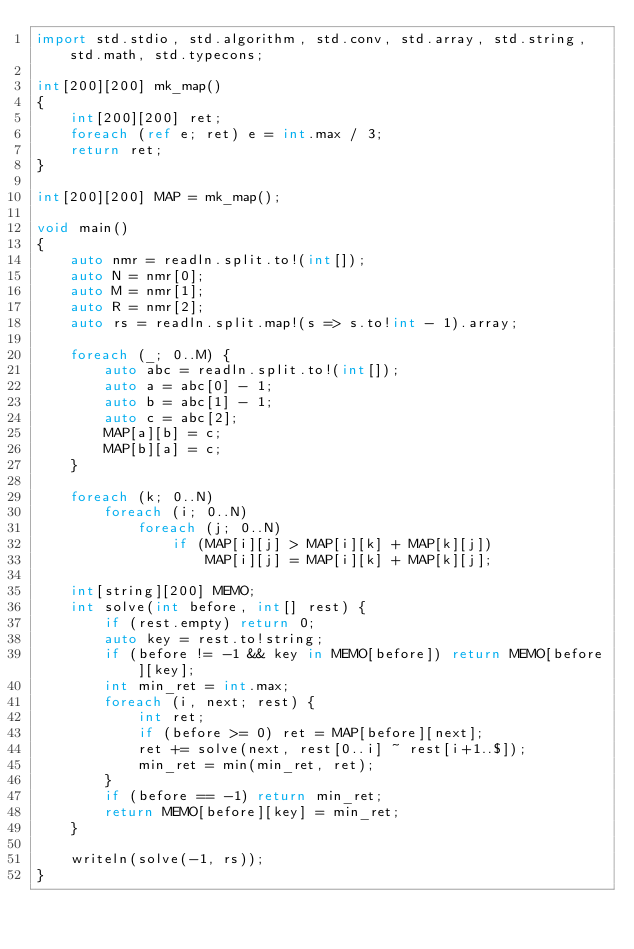Convert code to text. <code><loc_0><loc_0><loc_500><loc_500><_D_>import std.stdio, std.algorithm, std.conv, std.array, std.string, std.math, std.typecons;

int[200][200] mk_map()
{
    int[200][200] ret;
    foreach (ref e; ret) e = int.max / 3;
    return ret;
}

int[200][200] MAP = mk_map();

void main()
{
    auto nmr = readln.split.to!(int[]);
    auto N = nmr[0];
    auto M = nmr[1];
    auto R = nmr[2];
    auto rs = readln.split.map!(s => s.to!int - 1).array;

    foreach (_; 0..M) {
        auto abc = readln.split.to!(int[]);
        auto a = abc[0] - 1;
        auto b = abc[1] - 1;
        auto c = abc[2];
        MAP[a][b] = c;
        MAP[b][a] = c;
    }

    foreach (k; 0..N)
        foreach (i; 0..N)
            foreach (j; 0..N)
                if (MAP[i][j] > MAP[i][k] + MAP[k][j])
                    MAP[i][j] = MAP[i][k] + MAP[k][j];

    int[string][200] MEMO;
    int solve(int before, int[] rest) {
        if (rest.empty) return 0;
        auto key = rest.to!string;
        if (before != -1 && key in MEMO[before]) return MEMO[before][key];
        int min_ret = int.max;
        foreach (i, next; rest) {
            int ret;
            if (before >= 0) ret = MAP[before][next];
            ret += solve(next, rest[0..i] ~ rest[i+1..$]);
            min_ret = min(min_ret, ret);
        }
        if (before == -1) return min_ret;
        return MEMO[before][key] = min_ret;
    }

    writeln(solve(-1, rs));
}</code> 